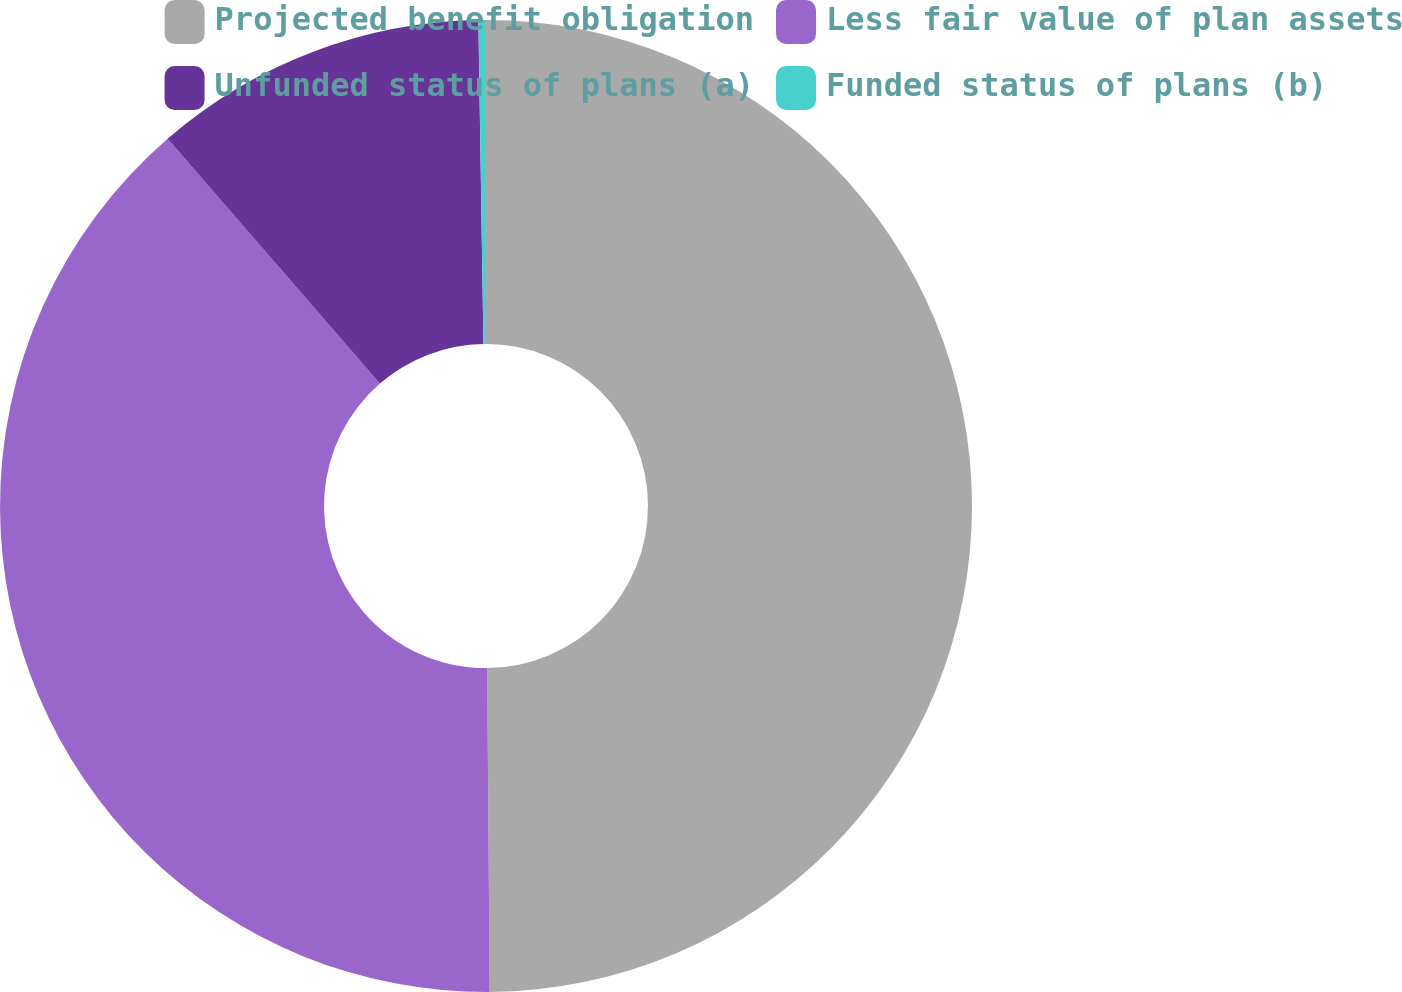<chart> <loc_0><loc_0><loc_500><loc_500><pie_chart><fcel>Projected benefit obligation<fcel>Less fair value of plan assets<fcel>Unfunded status of plans (a)<fcel>Funded status of plans (b)<nl><fcel>49.88%<fcel>38.75%<fcel>11.12%<fcel>0.25%<nl></chart> 